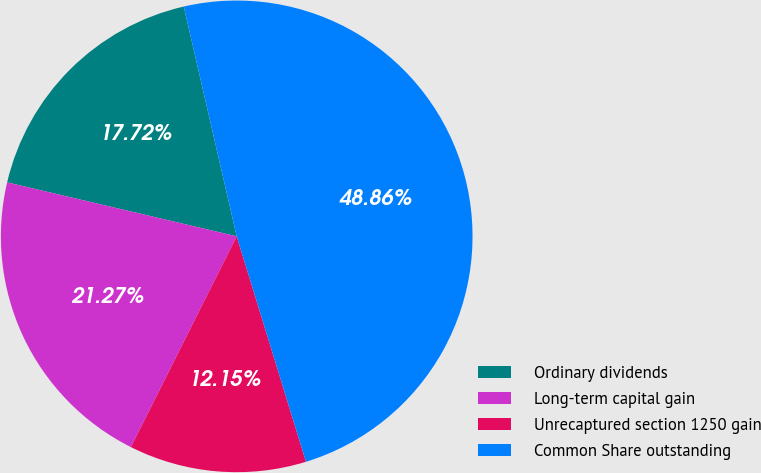Convert chart to OTSL. <chart><loc_0><loc_0><loc_500><loc_500><pie_chart><fcel>Ordinary dividends<fcel>Long-term capital gain<fcel>Unrecaptured section 1250 gain<fcel>Common Share outstanding<nl><fcel>17.72%<fcel>21.27%<fcel>12.15%<fcel>48.86%<nl></chart> 